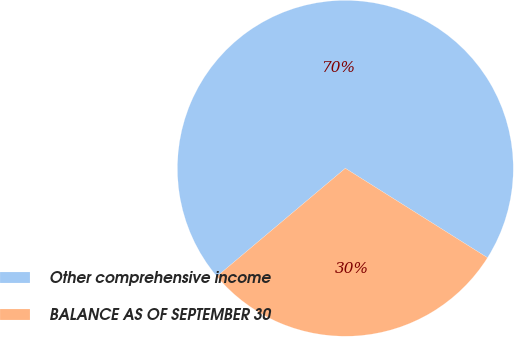Convert chart. <chart><loc_0><loc_0><loc_500><loc_500><pie_chart><fcel>Other comprehensive income<fcel>BALANCE AS OF SEPTEMBER 30<nl><fcel>70.07%<fcel>29.93%<nl></chart> 